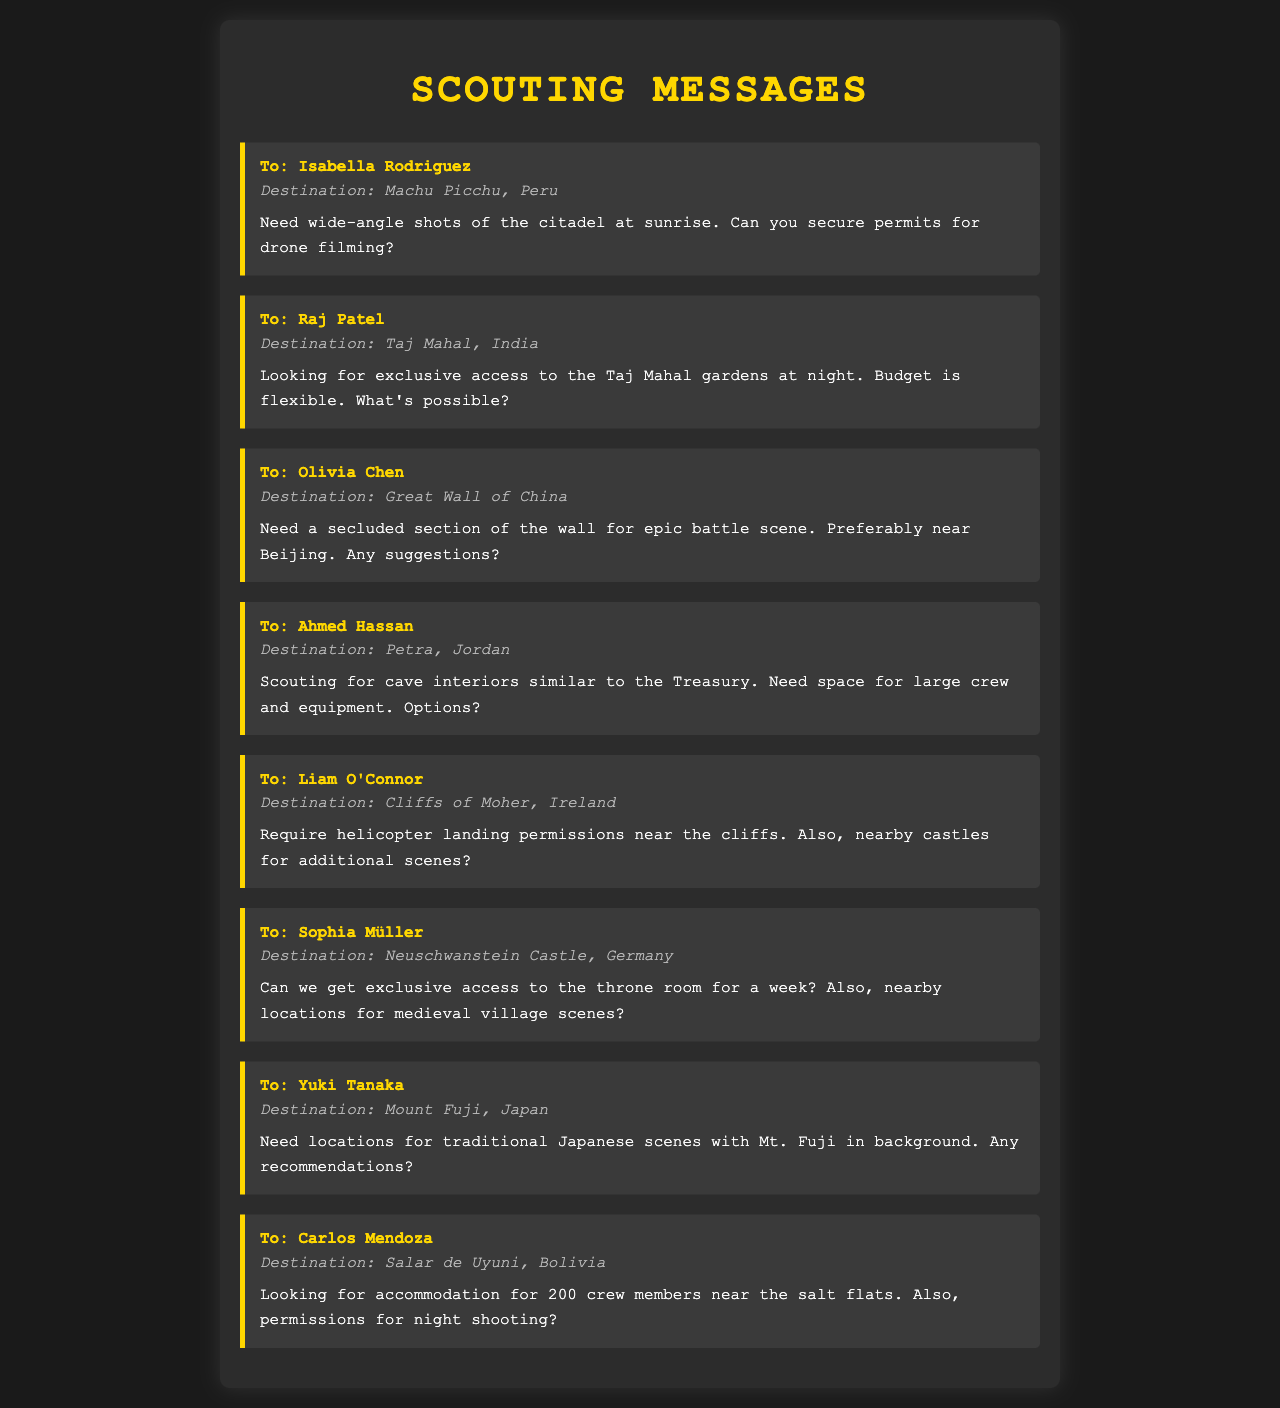What is the destination for Isabella Rodriguez? The document states that Isabella Rodriguez is assigned to Machu Picchu in Peru.
Answer: Machu Picchu, Peru What does Raj Patel want access to? Raj Patel is looking for exclusive access to the Taj Mahal gardens.
Answer: Taj Mahal gardens Who is scouting locations near Beijing? Olivia Chen is scouting locations near Beijing for the Great Wall of China.
Answer: Olivia Chen How many crew members is Carlos Mendoza looking to accommodate? Carlos Mendoza is looking for accommodation for 200 crew members near the salt flats.
Answer: 200 What scene type does Ahmed Hassan need spaces for? Ahmed Hassan is scouting for cave interiors for a large crew and equipment related to filming.
Answer: Cave interiors Which destination requires helicopter landing permissions? The Cliffs of Moher in Ireland require helicopter landing permissions.
Answer: Cliffs of Moher, Ireland What extra filming location does Sophia Müller inquire about? Sophia Müller also inquires about nearby locations for medieval village scenes.
Answer: Medieval village scenes How long does Sophia Müller want access to the throne room? Sophia Müller wants exclusive access to the throne room for a week.
Answer: A week 